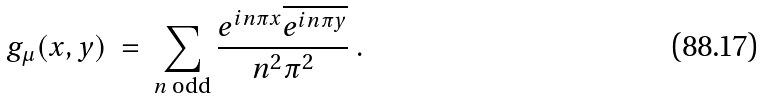Convert formula to latex. <formula><loc_0><loc_0><loc_500><loc_500>g _ { \mu } ( x , y ) \ = \ \sum _ { \substack { \text {$n$ odd} } } \frac { e ^ { i n \pi x } \overline { e ^ { i n \pi y } } } { n ^ { 2 } \pi ^ { 2 } } \ .</formula> 